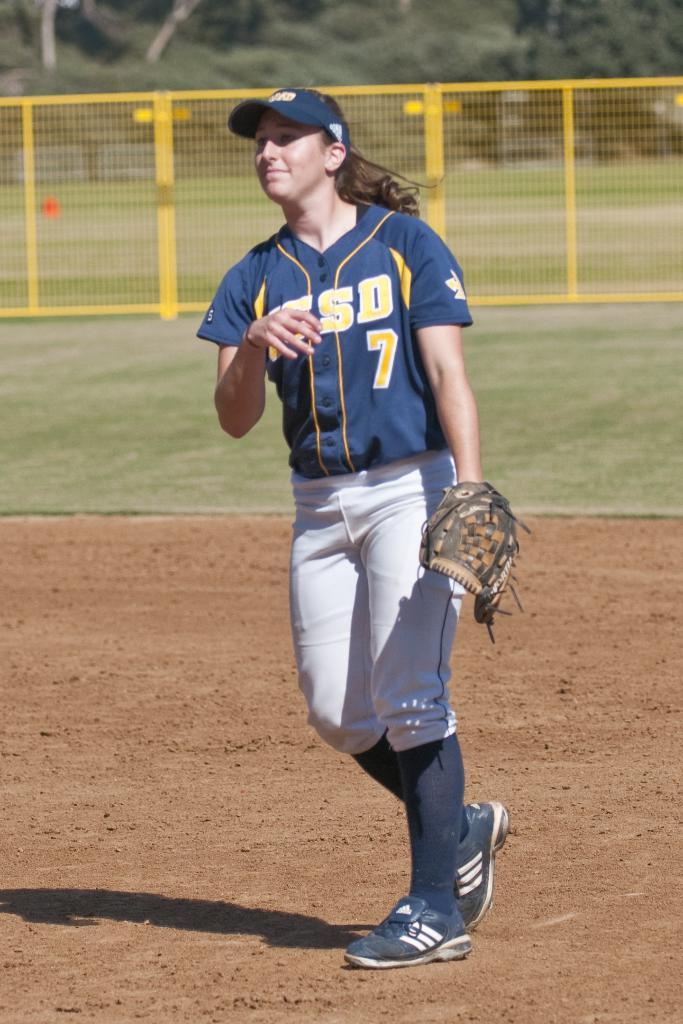What number is on the girl's jersey?
Offer a terse response. 7. What initials can be read on her jersey?
Offer a very short reply. Sd. 